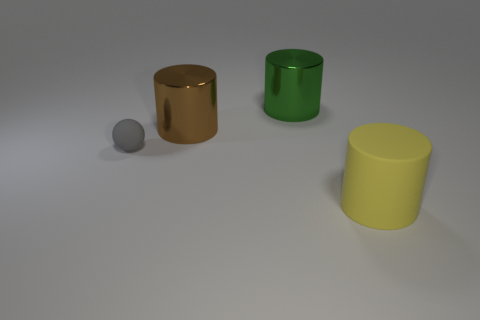Add 1 rubber things. How many objects exist? 5 Subtract all spheres. How many objects are left? 3 Subtract 0 brown balls. How many objects are left? 4 Subtract all big purple rubber balls. Subtract all brown cylinders. How many objects are left? 3 Add 3 large green cylinders. How many large green cylinders are left? 4 Add 1 tiny rubber things. How many tiny rubber things exist? 2 